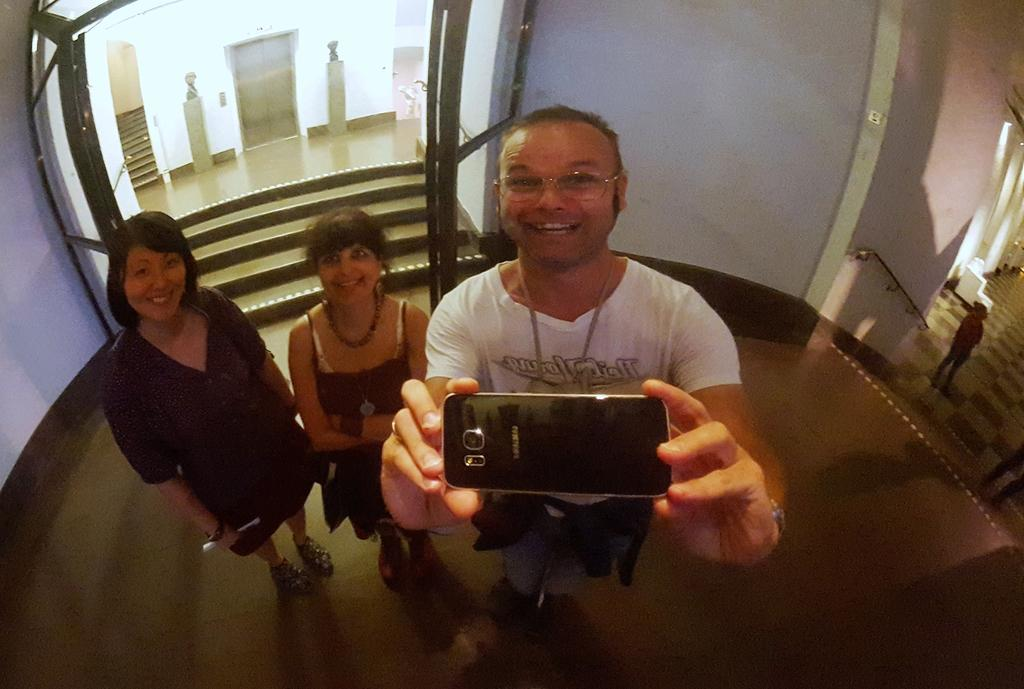How many people are in the image? There are three individuals in the image: two women and a man. What is the emotional expression of the people in the image? All three individuals are smiling in the image. What is the man holding in the image? The man is holding a mobile in the image. What architectural features can be seen in the background of the image? There are steps, a door, and a wall visible in the background of the image. Can you see any hills in the background of the image? There are no hills visible in the background of the image. Are there any bubbles floating around the people in the image? There are no bubbles present in the image. 